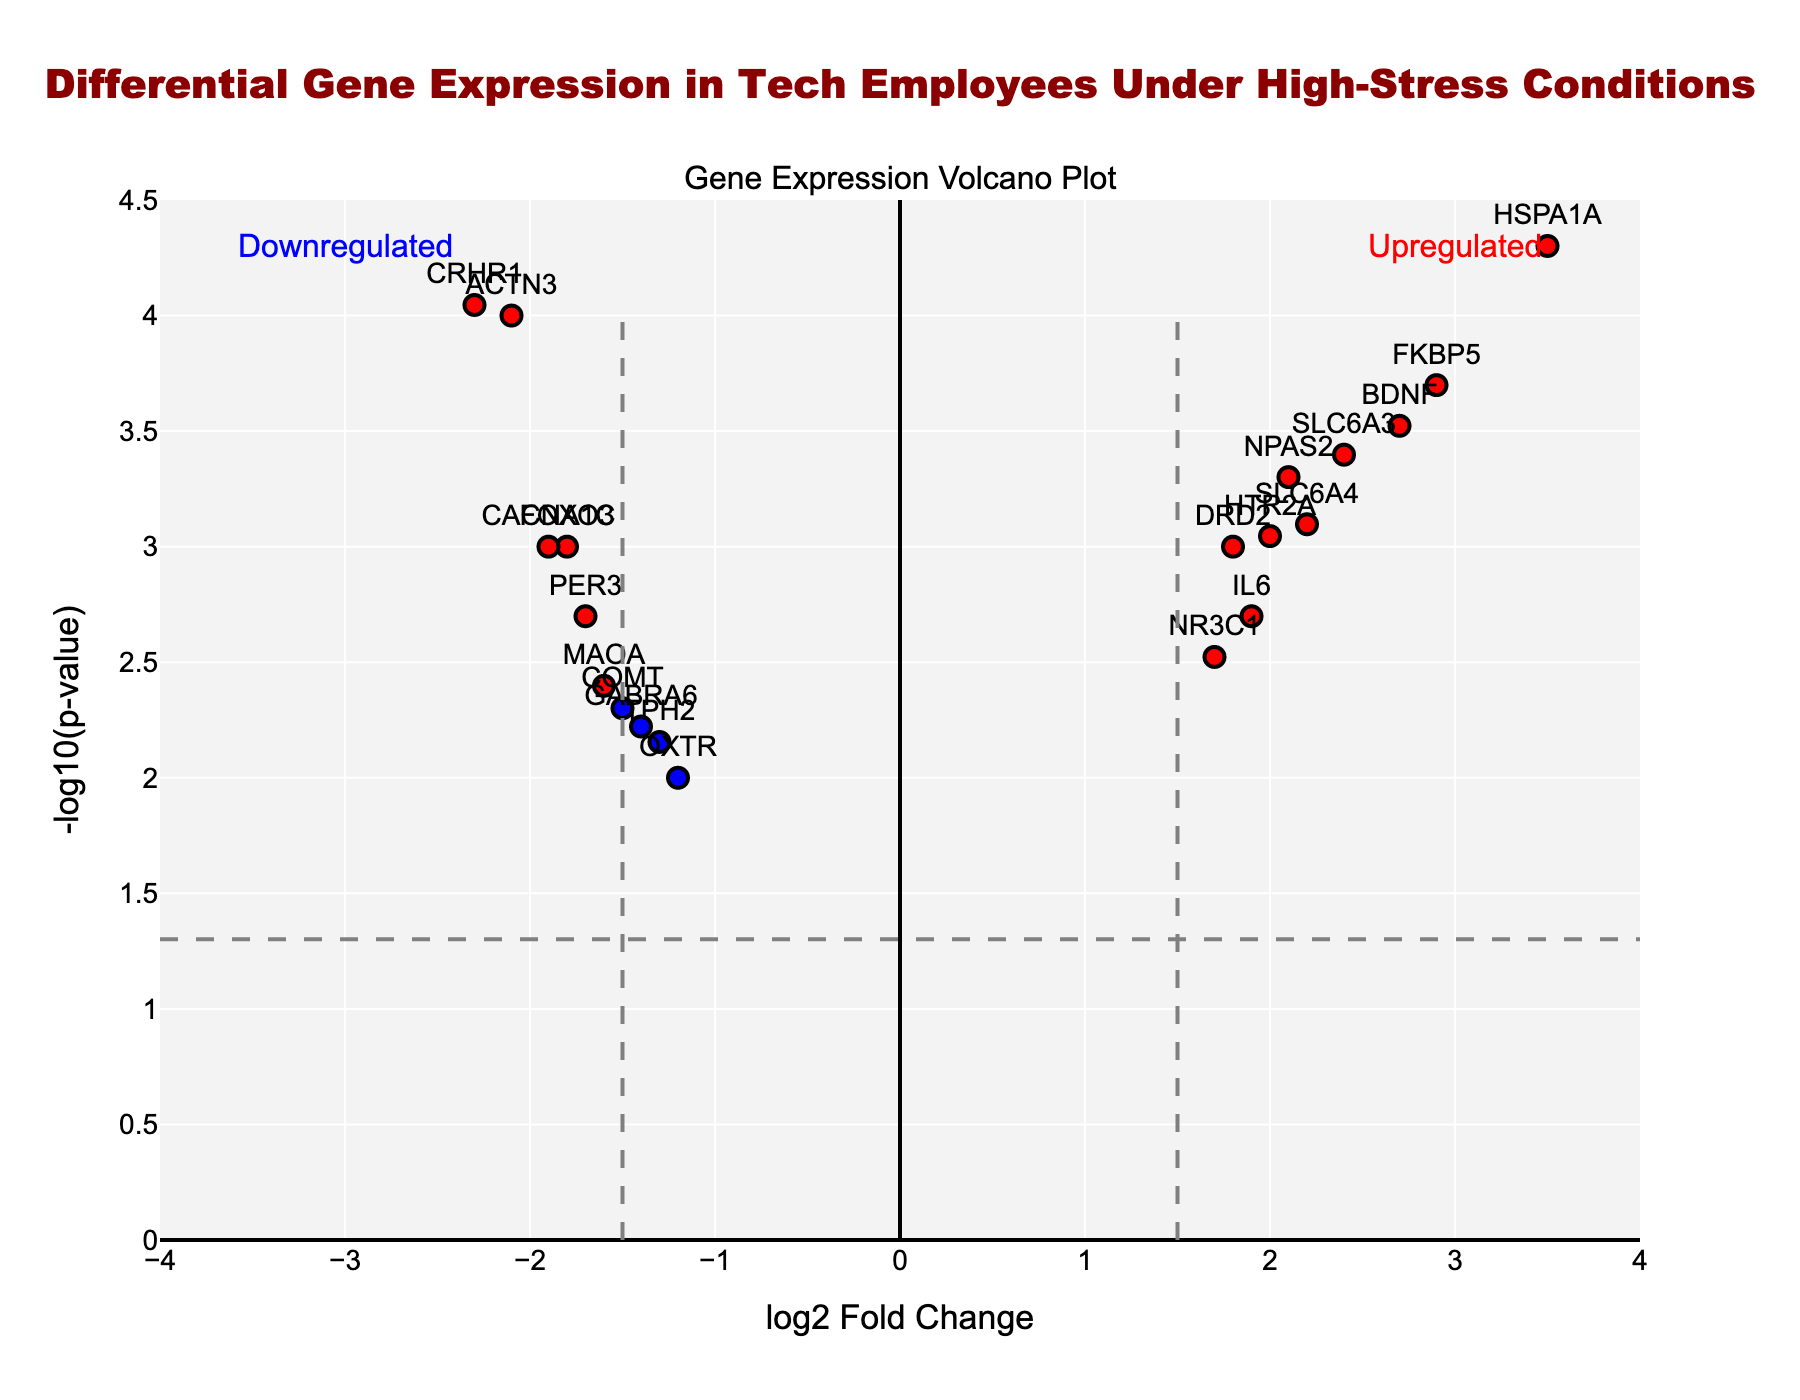What's the title of this plot? The title is located at the top of the plot and it reads, "Differential Gene Expression in Tech Employees Under High-Stress Conditions."
Answer: Differential Gene Expression in Tech Employees Under High-Stress Conditions What are the axes titles of the plot? The x-axis title is "log2 Fold Change" and the y-axis title is "-log10(p-value)." You can find these titles along the bottom and left-hand side of the axes, respectively.
Answer: log2 Fold Change and -log10(p-value) How many data points are in this figure? Each gene appears as a dot in the figure. Counting all the points in the plot, we get 18 data points (genes shown as markers).
Answer: 18 Which genes are the most significantly upregulated and downregulated? Significance is determined by the p-value, and "HSPA1A" (log2FC = 3.5) and "CRHR1" (log2FC = -2.3) have the smallest p-values, as seen from their position highest on the y-axis and farthest from zero on the x-axis among their respective up/down groups.
Answer: HSPA1A and CRHR1 Which gene has the highest log2 Fold Change and what does this indicate? The X-axis represents log2 Fold Change. "HSPA1A" has the highest log2 Fold Change of 3.5, indicating it is the most upregulated gene.
Answer: HSPA1A How many genes show a p-value less than 0.001? To find this, locate the horizontal threshold line for -log10(p-value) = 3 (since -log10(0.001) = 3). Count the number of points above this line: ACTN3, HSPA1A, BDNF, FKBP5, CRHR1, and NPAS2. There are 6 genes.
Answer: 6 Which genes are significantly downregulated according to the threshold lines? Significant downregulation occurs when the log2 Fold Change is less than -1.5 and the p-value is less than 0.05. The genes meeting these criteria are ACTN3, FOXO3, COMT, CRHR1, and CACNA1C.
Answer: ACTN3, FOXO3, COMT, CRHR1, and CACNA1C How many genes are colored in red and what does this signify? Red indicators mean the genes are significantly up or downregulated with a log2 Fold Change greater than 1.5 (or less than -1.5) and a p-value less than 0.05. By counting the red dots, we find 10 genes.
Answer: 10 Which genes fall within the gray color category and what do they represent? Gray colored genes do not meet either threshold for significant differential expression (log2 Fold Change ≤ 1.5 and p-value ≥ 0.05). By identifying these genes, we find OXTR and TPH2 in the gray category.
Answer: OXTR and TPH2 